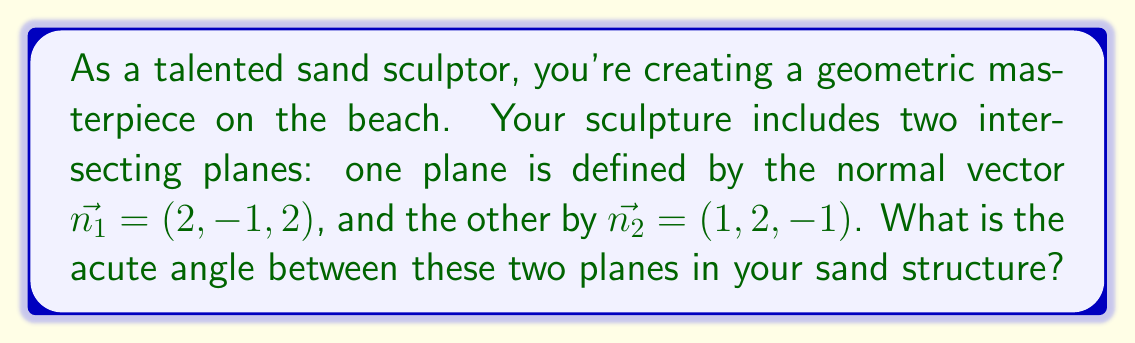Help me with this question. To find the angle between two planes, we can use the angle between their normal vectors. The formula for the angle $\theta$ between two vectors $\vec{a}$ and $\vec{b}$ is:

$$\cos \theta = \frac{\vec{a} \cdot \vec{b}}{|\vec{a}||\vec{b}|}$$

Where $\vec{a} \cdot \vec{b}$ is the dot product and $|\vec{a}|$ and $|\vec{b}|$ are the magnitudes of the vectors.

Step 1: Calculate the dot product of $\vec{n_1}$ and $\vec{n_2}$:
$$\vec{n_1} \cdot \vec{n_2} = (2)(1) + (-1)(2) + (2)(-1) = 2 - 2 - 2 = -2$$

Step 2: Calculate the magnitudes of $\vec{n_1}$ and $\vec{n_2}$:
$$|\vec{n_1}| = \sqrt{2^2 + (-1)^2 + 2^2} = \sqrt{9} = 3$$
$$|\vec{n_2}| = \sqrt{1^2 + 2^2 + (-1)^2} = \sqrt{6}$$

Step 3: Substitute into the formula:
$$\cos \theta = \frac{-2}{3\sqrt{6}}$$

Step 4: Take the inverse cosine (arccos) of both sides:
$$\theta = \arccos\left(\frac{-2}{3\sqrt{6}}\right)$$

Step 5: Calculate the result (in radians):
$$\theta \approx 2.0344 \text{ radians}$$

Step 6: Convert to degrees:
$$\theta \approx 116.57°$$

The acute angle is the complement of this angle:
$$\text{Acute angle} = 180° - 116.57° = 63.43°$$
Answer: The acute angle between the two planes in the sand sculpture is approximately 63.43°. 